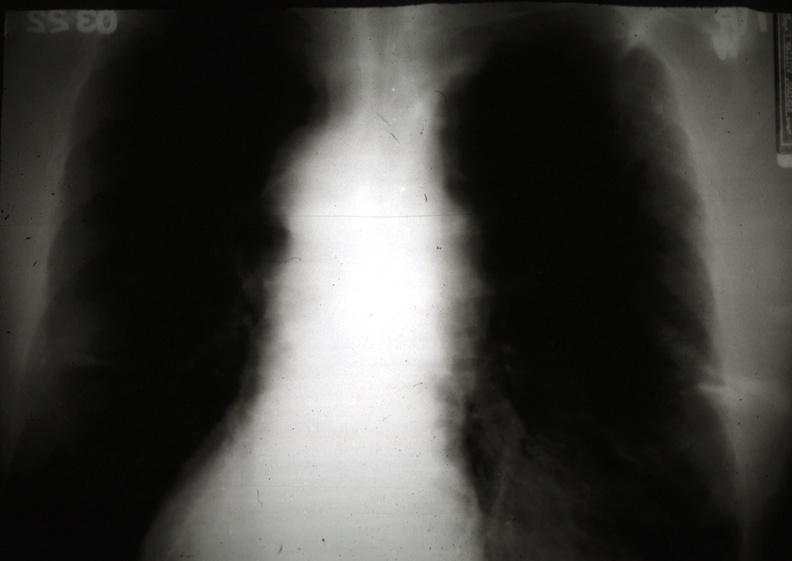does this image show x-ray chest showing mediastinal widening and fuzzy border?
Answer the question using a single word or phrase. Yes 